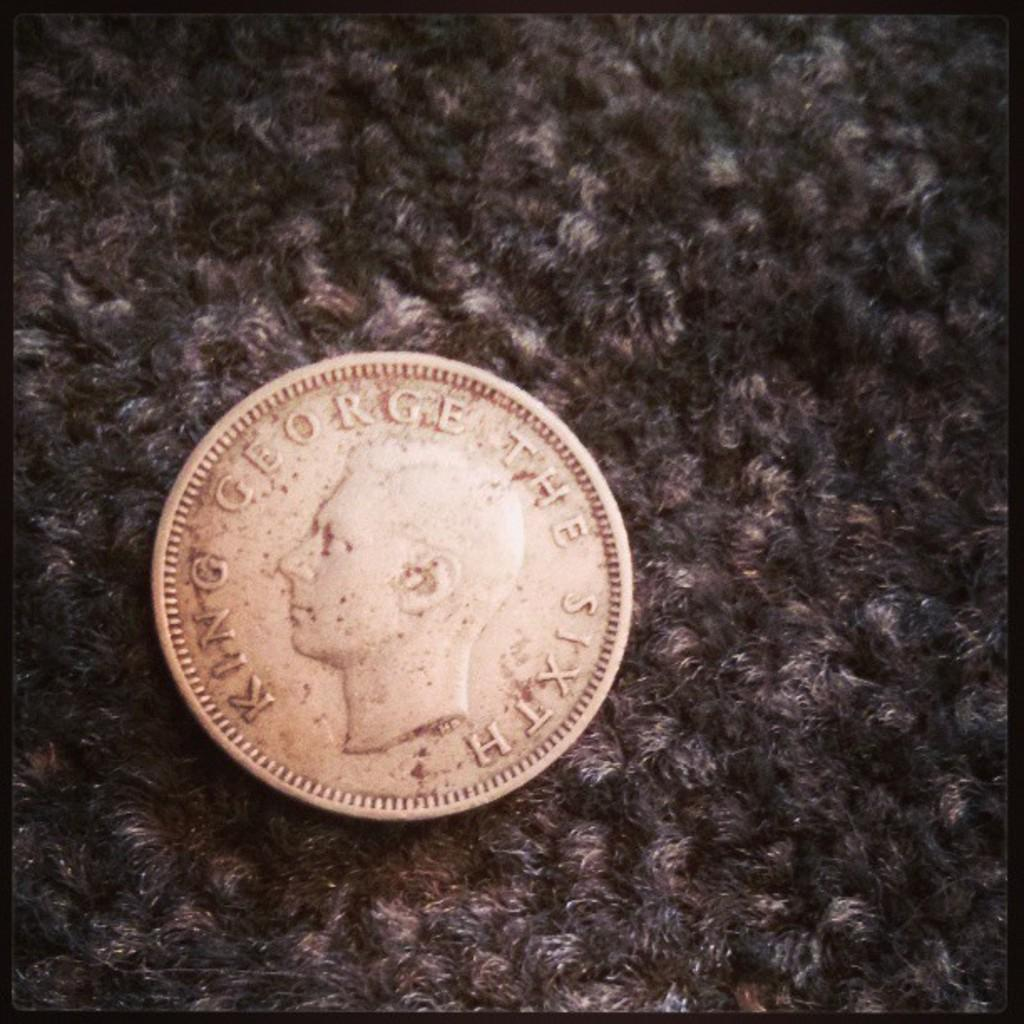<image>
Create a compact narrative representing the image presented. A coin featuring King George The Sixth sits on a carpet surface 